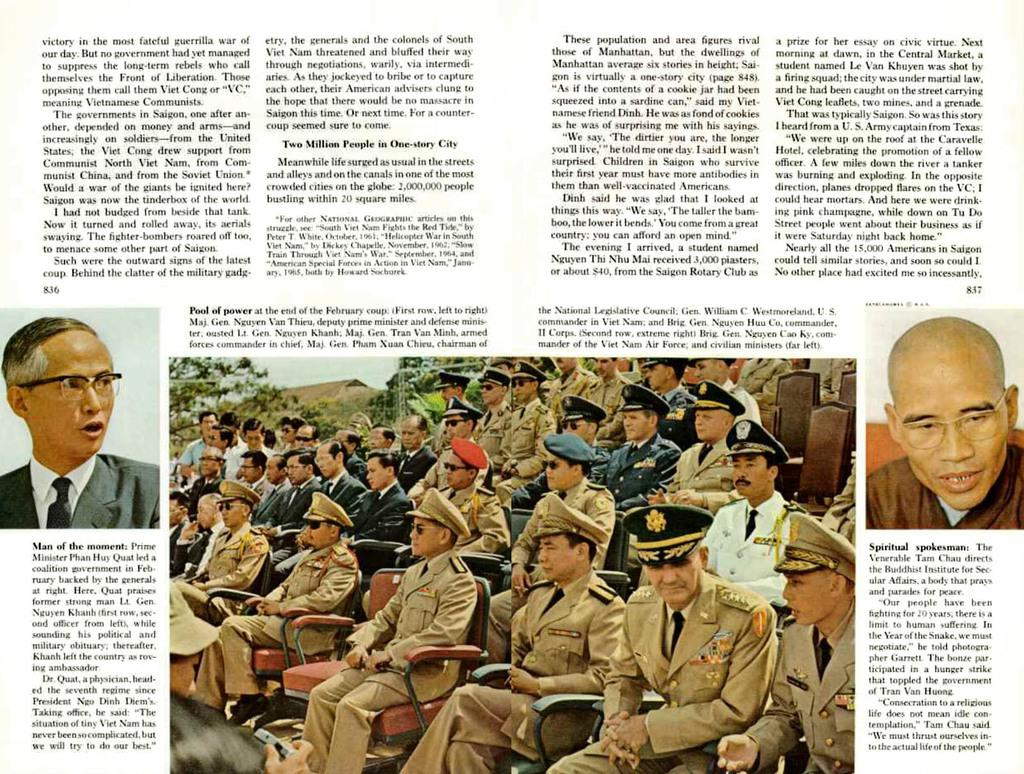What type of publication is shown in the image? The image is a newspaper. What can be seen in the images within the newspaper? There are images of persons in the newspaper. What color is the text in the newspaper? The text in the newspaper is black in color. What is the color of the background in the newspaper? The background of the newspaper is white in color. How many ducks are visible in the image? There are no ducks present in the image; it is a newspaper with text and images of persons. What type of parcel is being delivered in the image? There is no parcel delivery depicted in the image; it is a newspaper with text and images of persons. 